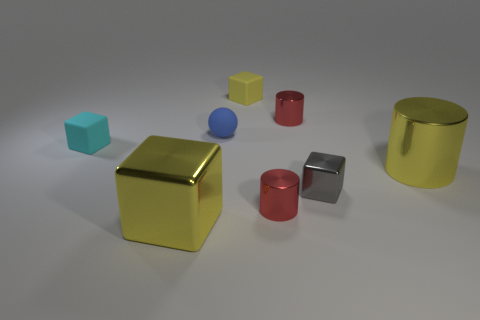Is the size of the gray metallic object the same as the yellow metal block?
Offer a terse response. No. Are there any yellow shiny cylinders?
Offer a terse response. Yes. There is a metal object that is the same color as the big cylinder; what size is it?
Your answer should be very brief. Large. There is a metal cube to the right of the block behind the tiny shiny object behind the small cyan matte thing; what size is it?
Ensure brevity in your answer.  Small. What number of tiny spheres are the same material as the gray block?
Your answer should be very brief. 0. What number of yellow cylinders are the same size as the blue object?
Your answer should be very brief. 0. What is the material of the tiny cube to the left of the big thing that is in front of the big yellow object behind the large block?
Provide a short and direct response. Rubber. How many things are either purple cylinders or small red metal cylinders?
Offer a terse response. 2. Are there any other things that are the same material as the cyan thing?
Ensure brevity in your answer.  Yes. There is a small gray thing; what shape is it?
Keep it short and to the point. Cube. 